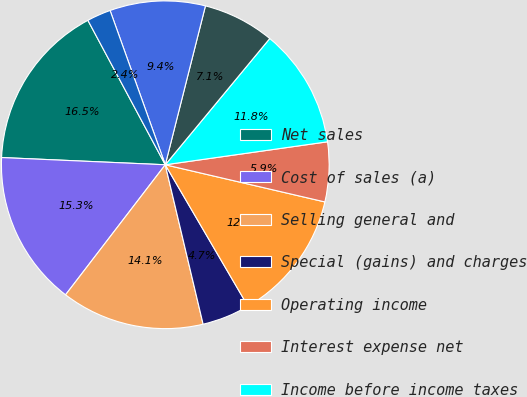Convert chart. <chart><loc_0><loc_0><loc_500><loc_500><pie_chart><fcel>Net sales<fcel>Cost of sales (a)<fcel>Selling general and<fcel>Special (gains) and charges<fcel>Operating income<fcel>Interest expense net<fcel>Income before income taxes<fcel>Provision for income taxes<fcel>Net income including<fcel>Net income attributable to<nl><fcel>16.47%<fcel>15.29%<fcel>14.12%<fcel>4.71%<fcel>12.94%<fcel>5.88%<fcel>11.76%<fcel>7.06%<fcel>9.41%<fcel>2.36%<nl></chart> 